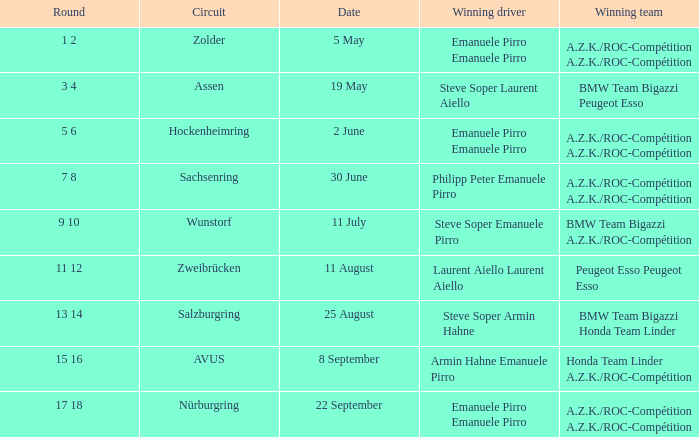Who emerged as the victorious driver in the race on may 5th? Emanuele Pirro Emanuele Pirro. 